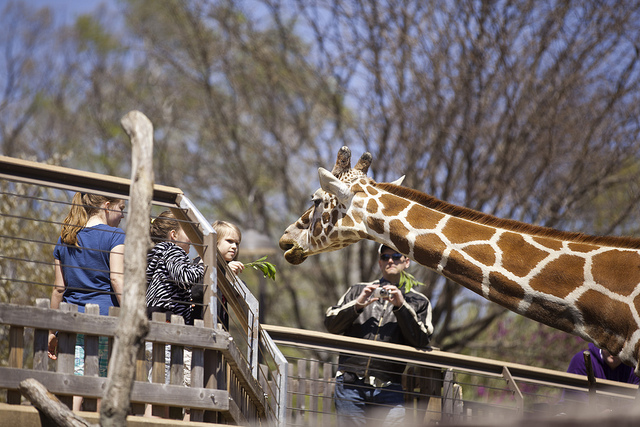What is significant about this image? This image captures a moment of human-animal interaction, highlighting the opportunities that zoos and wildlife parks provide for public education and engagement with species that one might not ordinarily encounter. Such moments raise awareness and can inspire conservation efforts. 